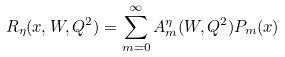Convert formula to latex. <formula><loc_0><loc_0><loc_500><loc_500>R _ { \eta } ( x , W , Q ^ { 2 } ) = \sum _ { m = 0 } ^ { \infty } A ^ { \eta } _ { m } ( W , Q ^ { 2 } ) P _ { m } ( x )</formula> 